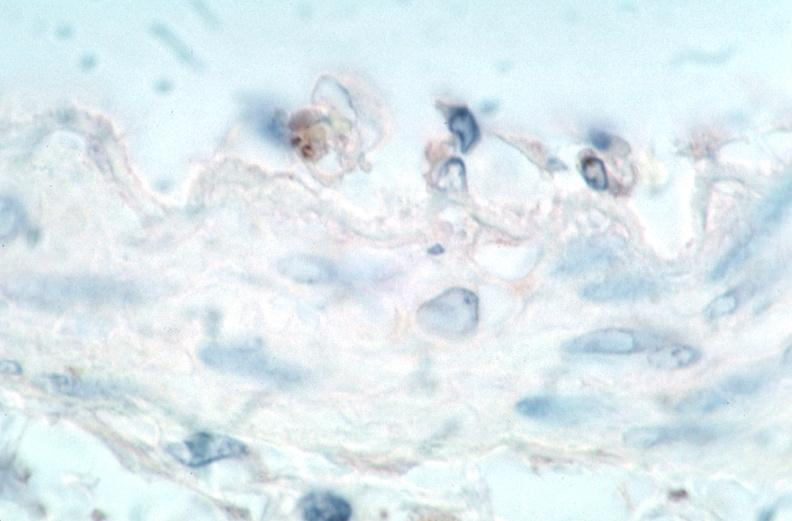s intraductal papillomatosis present?
Answer the question using a single word or phrase. No 